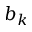<formula> <loc_0><loc_0><loc_500><loc_500>b _ { k }</formula> 